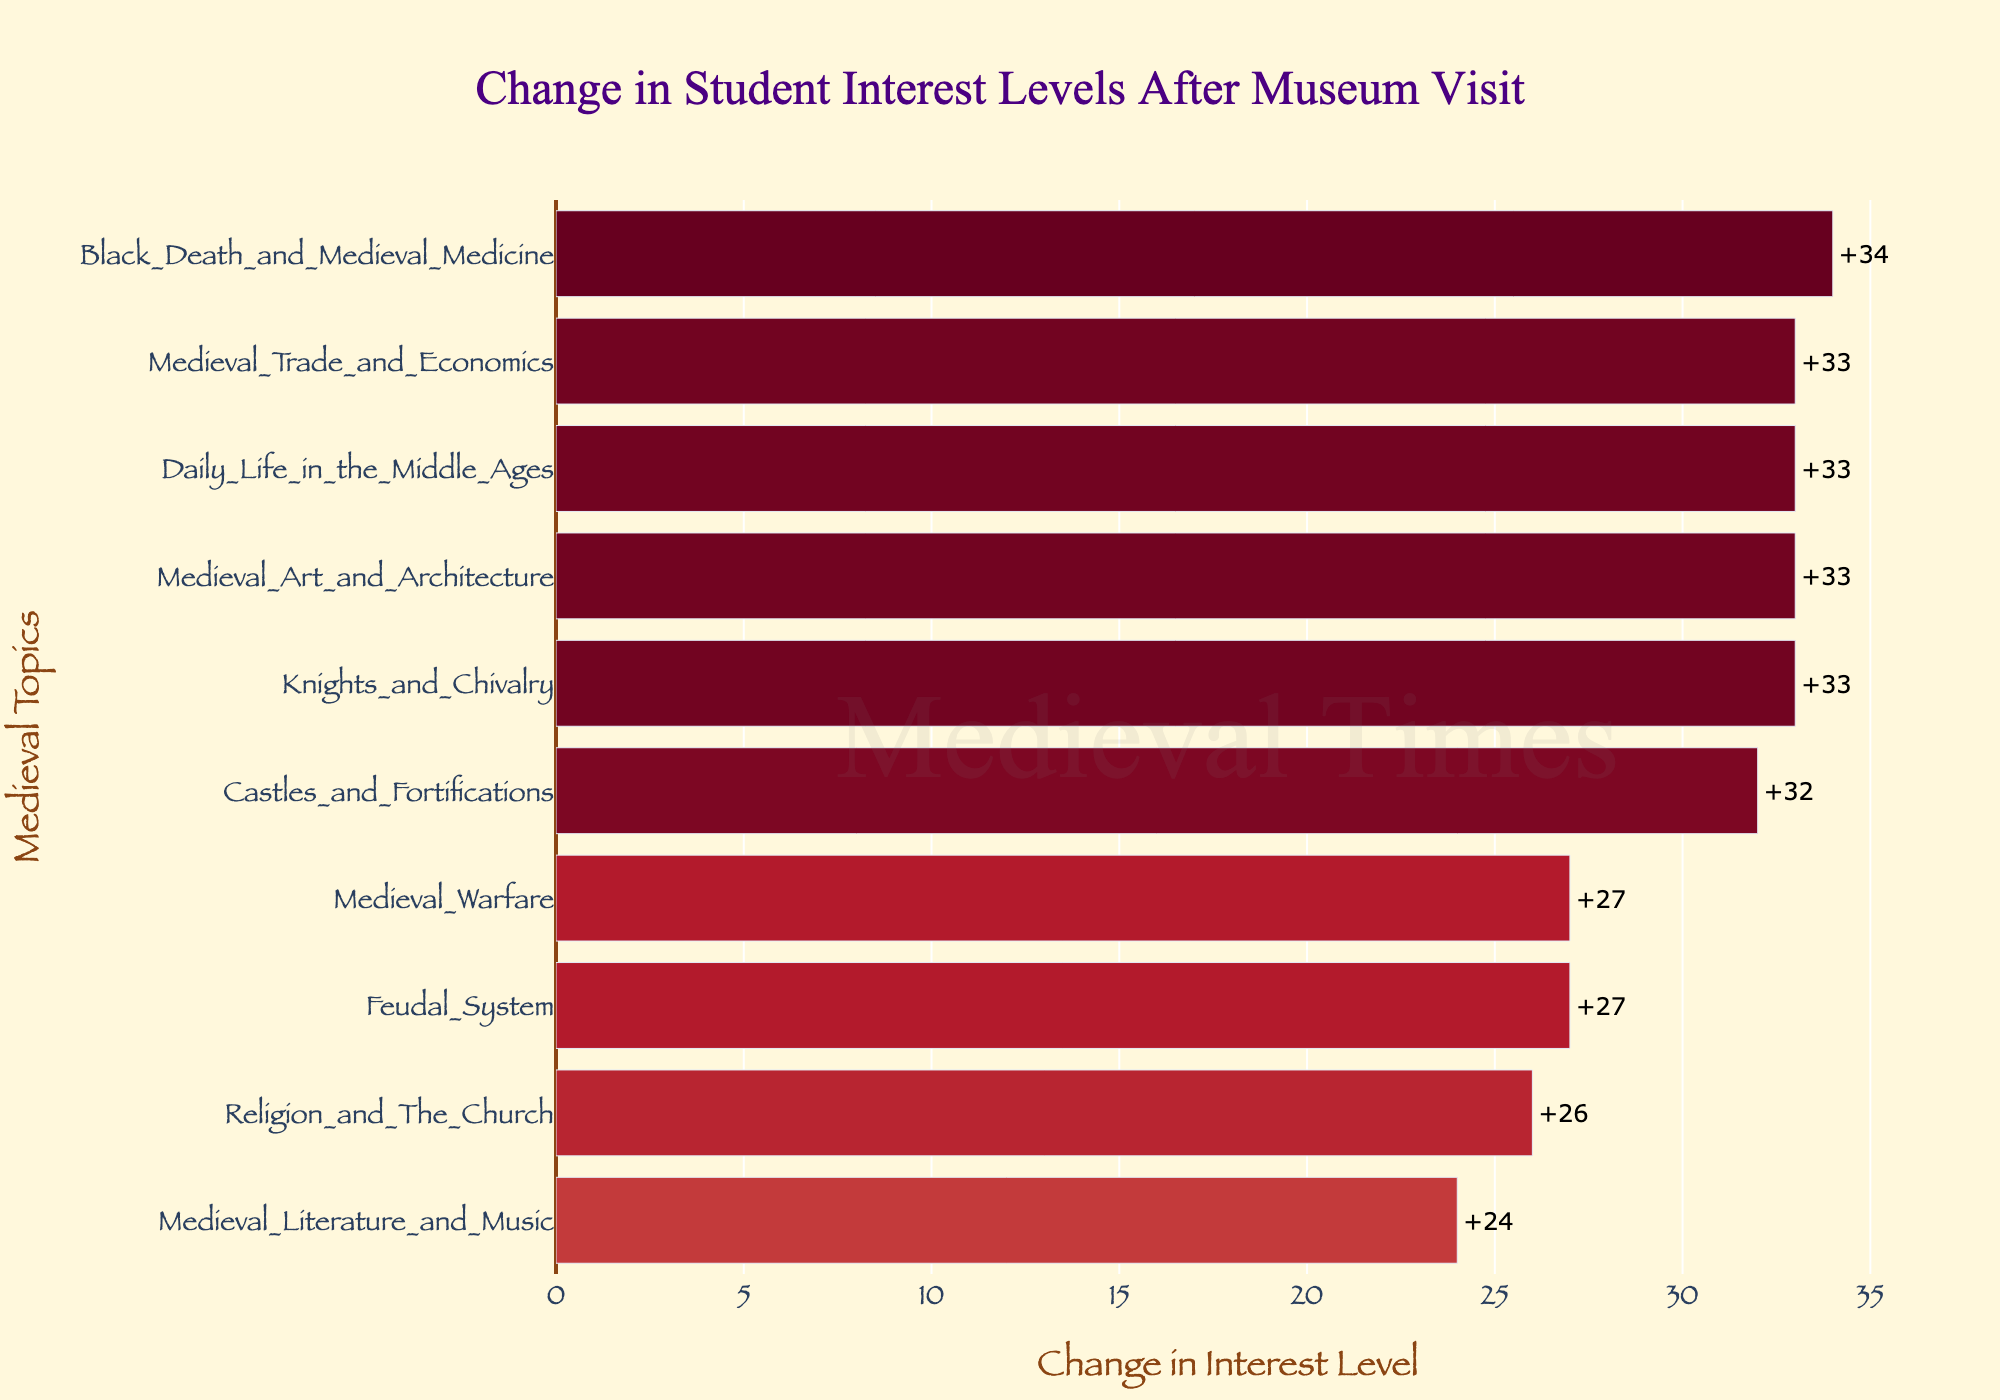What's the largest increase in student interest levels? Look at the largest value bar. "Black Death and Medieval Medicine" shows the largest increase, reaching 34.
Answer: 34 What's the smallest increase in student interest levels? Look at the smallest value bar. "Feudal System" shows the smallest increase, reaching 27.
Answer: 27 Which topic experienced the highest increase in interest levels? Identify the bar with the maximum increase (highest positive value). "Black Death and Medieval Medicine" experienced the highest increase of +34.
Answer: Black Death and Medieval Medicine Which topic had an increase of less than 30 points? Look at the bars with increases smaller than 30. "Feudal System" had an increase of 27 points.
Answer: Feudal System Compare the increase in interest levels between "Knights and Chivalry" and "Daily Life in the Middle Ages". Which one is higher and by how much? Calculate the difference between the increases. "Knights and Chivalry" increased by 33, and "Daily Life in the Middle Ages" by 33. The difference is 0.
Answer: Same What's the total increase in interest levels for all topics combined? Sum the increases for each topic: 33 + 33 + 27 + 33 + 27 + 32 + 33 + 26 + 24 + 34 = 302. The total increase is 302.
Answer: 302 Which topic saw a greater increase, "Medieval Art and Architecture" or "Religion and The Church"? Compare the values. "Medieval Art and Architecture" increased by 33, and "Religion and The Church" by 26. So, "Medieval Art and Architecture" saw a greater increase.
Answer: Medieval Art and Architecture By how much did "Medieval Trade and Economics" increase in interest levels? Look at the value for "Medieval Trade and Economics". The increase was 33.
Answer: 33 How many topics saw an increase of 30 points or more? Count the number of bars with an increase of 30 or more. There are 7 topics: "Knights and Chivalry", "Medieval Art and Architecture", "Daily Life in the Middle Ages", "Medieval Warfare", "Castles and Fortifications", "Medieval Trade and Economics", and "Black Death and Medieval Medicine".
Answer: 7 What is the average increase in interest levels across all topics? Total increase is 302, and there are 10 topics. Average increase = 302 / 10 = 30.2.
Answer: 30.2 